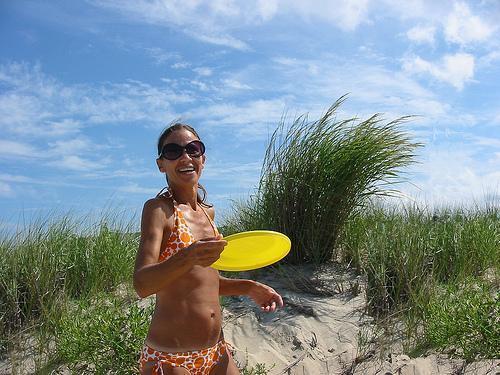How many frisbees?
Give a very brief answer. 1. 